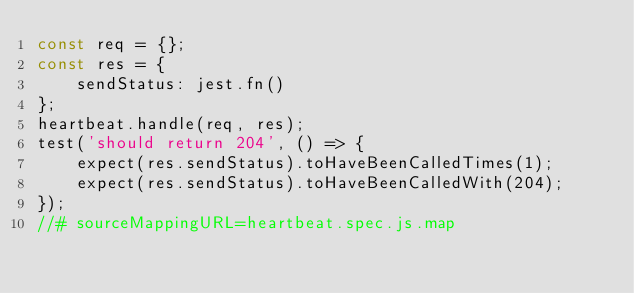<code> <loc_0><loc_0><loc_500><loc_500><_JavaScript_>const req = {};
const res = {
    sendStatus: jest.fn()
};
heartbeat.handle(req, res);
test('should return 204', () => {
    expect(res.sendStatus).toHaveBeenCalledTimes(1);
    expect(res.sendStatus).toHaveBeenCalledWith(204);
});
//# sourceMappingURL=heartbeat.spec.js.map</code> 